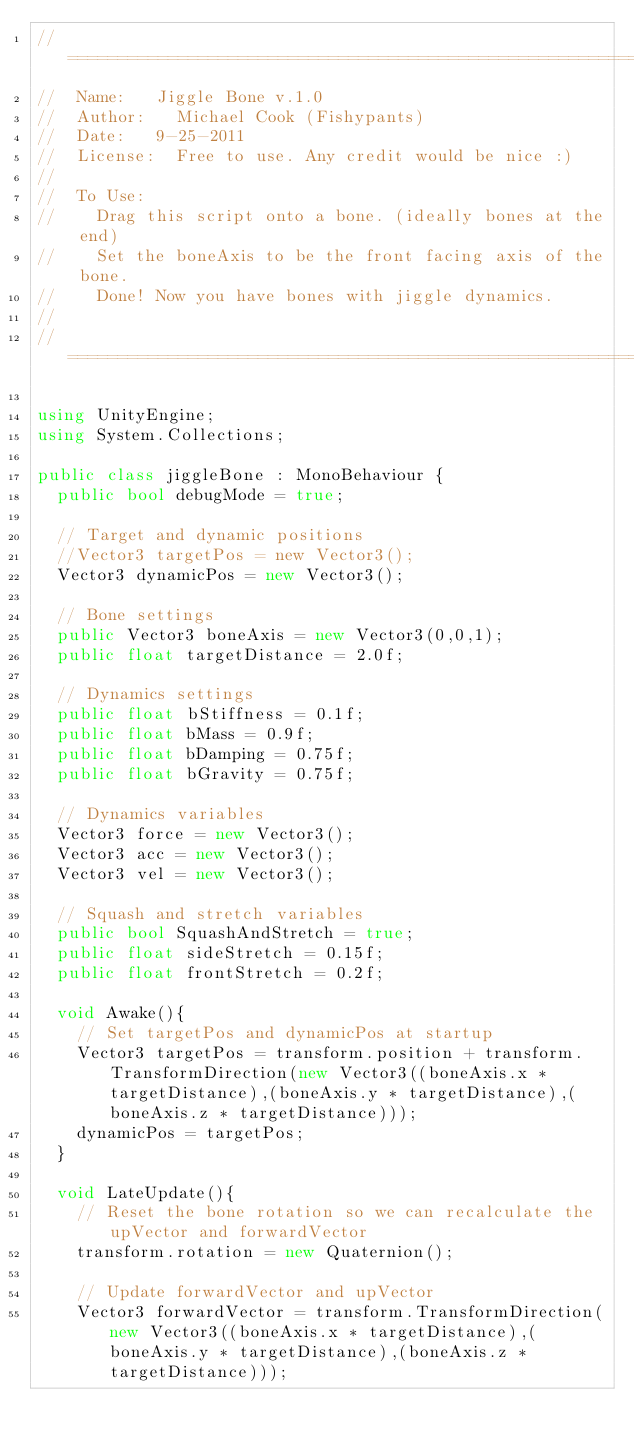Convert code to text. <code><loc_0><loc_0><loc_500><loc_500><_C#_>//	============================================================
//	Name:		Jiggle Bone v.1.0
//	Author: 	Michael Cook (Fishypants)
//	Date:		9-25-2011
//	License:	Free to use. Any credit would be nice :)
//
//	To Use:
// 		Drag this script onto a bone. (ideally bones at the end)
//		Set the boneAxis to be the front facing axis of the bone.
//		Done! Now you have bones with jiggle dynamics.
//
//	============================================================
 
using UnityEngine;
using System.Collections;
 
public class jiggleBone : MonoBehaviour {
	public bool debugMode = true;
 
	// Target and dynamic positions
	//Vector3 targetPos = new Vector3();
	Vector3 dynamicPos = new Vector3();
 
	// Bone settings
	public Vector3 boneAxis = new Vector3(0,0,1);
	public float targetDistance = 2.0f;
 
	// Dynamics settings
	public float bStiffness = 0.1f;
	public float bMass = 0.9f;
	public float bDamping = 0.75f;
	public float bGravity = 0.75f;
 
	// Dynamics variables
	Vector3 force = new Vector3();
	Vector3 acc = new Vector3();
	Vector3 vel = new Vector3();
 
	// Squash and stretch variables
	public bool SquashAndStretch = true;
	public float sideStretch = 0.15f;
	public float frontStretch = 0.2f;
 
	void Awake(){
		// Set targetPos and dynamicPos at startup
		Vector3 targetPos = transform.position + transform.TransformDirection(new Vector3((boneAxis.x * targetDistance),(boneAxis.y * targetDistance),(boneAxis.z * targetDistance)));
		dynamicPos = targetPos;
	}
 
	void LateUpdate(){
		// Reset the bone rotation so we can recalculate the upVector and forwardVector
		transform.rotation = new Quaternion();
 
		// Update forwardVector and upVector
		Vector3 forwardVector = transform.TransformDirection(new Vector3((boneAxis.x * targetDistance),(boneAxis.y * targetDistance),(boneAxis.z * targetDistance)));</code> 